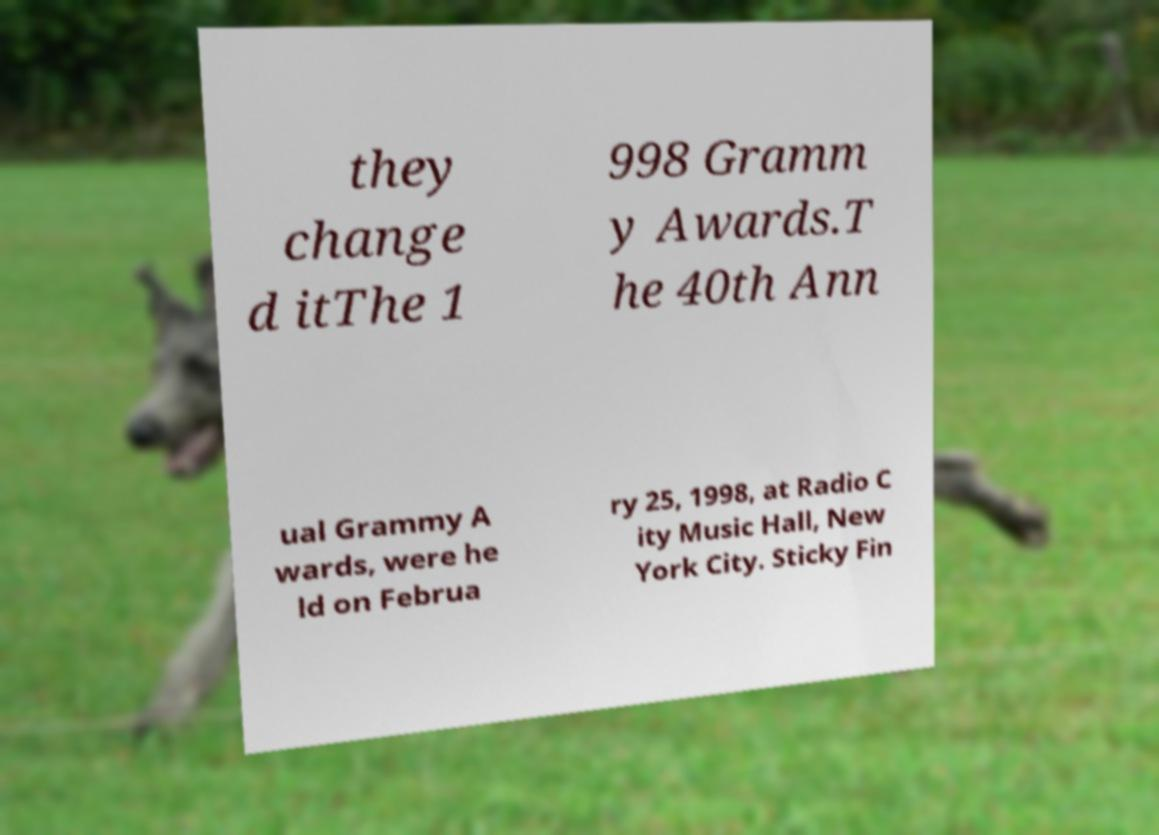Could you assist in decoding the text presented in this image and type it out clearly? they change d itThe 1 998 Gramm y Awards.T he 40th Ann ual Grammy A wards, were he ld on Februa ry 25, 1998, at Radio C ity Music Hall, New York City. Sticky Fin 